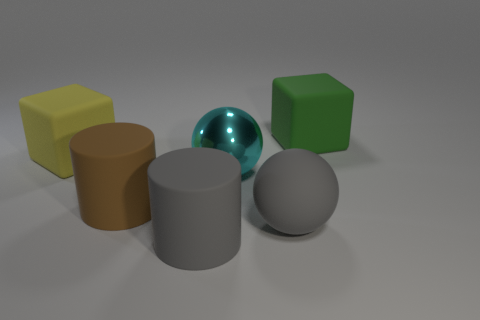Which objects in the image have reflective surfaces? The sphere in the center has a reflective surface, which is evident by the way it mirrors its surroundings with a shiny appearance. 